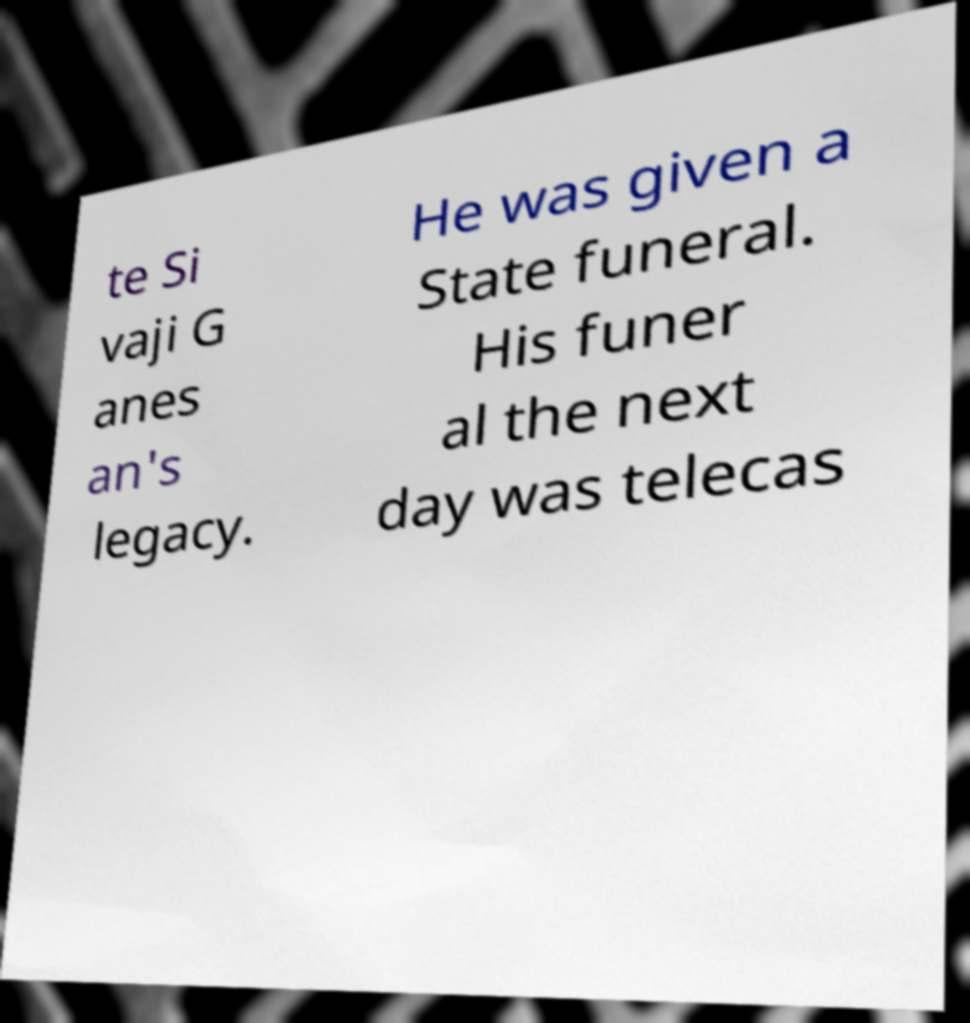I need the written content from this picture converted into text. Can you do that? te Si vaji G anes an's legacy. He was given a State funeral. His funer al the next day was telecas 